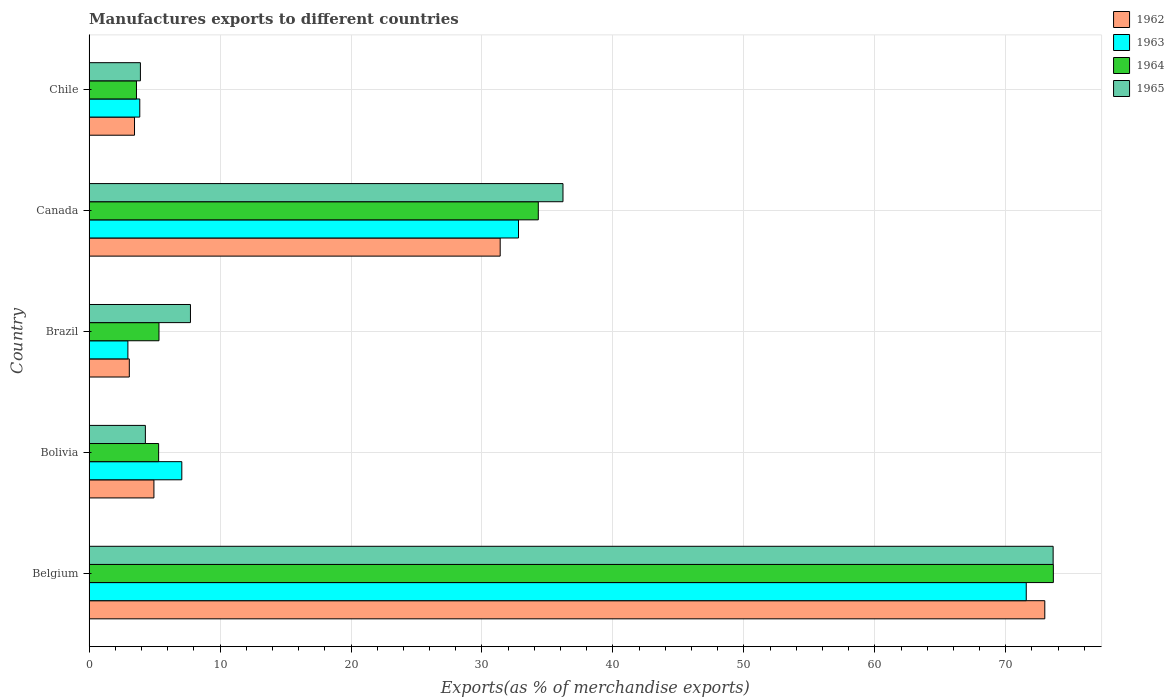How many different coloured bars are there?
Your answer should be compact. 4. How many groups of bars are there?
Your response must be concise. 5. Are the number of bars per tick equal to the number of legend labels?
Keep it short and to the point. Yes. Are the number of bars on each tick of the Y-axis equal?
Offer a very short reply. Yes. How many bars are there on the 3rd tick from the top?
Provide a short and direct response. 4. How many bars are there on the 3rd tick from the bottom?
Offer a terse response. 4. What is the percentage of exports to different countries in 1965 in Belgium?
Make the answer very short. 73.62. Across all countries, what is the maximum percentage of exports to different countries in 1964?
Offer a terse response. 73.63. Across all countries, what is the minimum percentage of exports to different countries in 1965?
Give a very brief answer. 3.92. In which country was the percentage of exports to different countries in 1964 maximum?
Give a very brief answer. Belgium. What is the total percentage of exports to different countries in 1962 in the graph?
Provide a short and direct response. 115.86. What is the difference between the percentage of exports to different countries in 1965 in Bolivia and that in Canada?
Make the answer very short. -31.89. What is the difference between the percentage of exports to different countries in 1965 in Bolivia and the percentage of exports to different countries in 1964 in Belgium?
Provide a short and direct response. -69.34. What is the average percentage of exports to different countries in 1963 per country?
Your answer should be very brief. 23.65. What is the difference between the percentage of exports to different countries in 1963 and percentage of exports to different countries in 1964 in Brazil?
Offer a very short reply. -2.37. What is the ratio of the percentage of exports to different countries in 1965 in Belgium to that in Canada?
Keep it short and to the point. 2.03. Is the percentage of exports to different countries in 1964 in Brazil less than that in Canada?
Give a very brief answer. Yes. What is the difference between the highest and the second highest percentage of exports to different countries in 1964?
Offer a very short reply. 39.33. What is the difference between the highest and the lowest percentage of exports to different countries in 1965?
Provide a succinct answer. 69.7. Is it the case that in every country, the sum of the percentage of exports to different countries in 1964 and percentage of exports to different countries in 1962 is greater than the percentage of exports to different countries in 1965?
Provide a short and direct response. Yes. Are all the bars in the graph horizontal?
Provide a short and direct response. Yes. What is the difference between two consecutive major ticks on the X-axis?
Ensure brevity in your answer.  10. Does the graph contain any zero values?
Your answer should be compact. No. Does the graph contain grids?
Provide a succinct answer. Yes. Where does the legend appear in the graph?
Provide a succinct answer. Top right. How are the legend labels stacked?
Provide a short and direct response. Vertical. What is the title of the graph?
Your answer should be very brief. Manufactures exports to different countries. Does "1985" appear as one of the legend labels in the graph?
Offer a terse response. No. What is the label or title of the X-axis?
Provide a succinct answer. Exports(as % of merchandise exports). What is the Exports(as % of merchandise exports) in 1962 in Belgium?
Provide a short and direct response. 72.98. What is the Exports(as % of merchandise exports) in 1963 in Belgium?
Offer a terse response. 71.56. What is the Exports(as % of merchandise exports) in 1964 in Belgium?
Offer a terse response. 73.63. What is the Exports(as % of merchandise exports) of 1965 in Belgium?
Your answer should be very brief. 73.62. What is the Exports(as % of merchandise exports) in 1962 in Bolivia?
Make the answer very short. 4.95. What is the Exports(as % of merchandise exports) in 1963 in Bolivia?
Provide a short and direct response. 7.08. What is the Exports(as % of merchandise exports) in 1964 in Bolivia?
Provide a short and direct response. 5.31. What is the Exports(as % of merchandise exports) of 1965 in Bolivia?
Your response must be concise. 4.3. What is the Exports(as % of merchandise exports) in 1962 in Brazil?
Your answer should be compact. 3.07. What is the Exports(as % of merchandise exports) in 1963 in Brazil?
Provide a short and direct response. 2.96. What is the Exports(as % of merchandise exports) of 1964 in Brazil?
Provide a short and direct response. 5.34. What is the Exports(as % of merchandise exports) in 1965 in Brazil?
Provide a short and direct response. 7.74. What is the Exports(as % of merchandise exports) of 1962 in Canada?
Your answer should be very brief. 31.39. What is the Exports(as % of merchandise exports) of 1963 in Canada?
Provide a short and direct response. 32.79. What is the Exports(as % of merchandise exports) of 1964 in Canada?
Provide a short and direct response. 34.3. What is the Exports(as % of merchandise exports) in 1965 in Canada?
Keep it short and to the point. 36.19. What is the Exports(as % of merchandise exports) in 1962 in Chile?
Provide a short and direct response. 3.47. What is the Exports(as % of merchandise exports) in 1963 in Chile?
Your response must be concise. 3.87. What is the Exports(as % of merchandise exports) of 1964 in Chile?
Your answer should be very brief. 3.62. What is the Exports(as % of merchandise exports) of 1965 in Chile?
Your answer should be very brief. 3.92. Across all countries, what is the maximum Exports(as % of merchandise exports) of 1962?
Offer a terse response. 72.98. Across all countries, what is the maximum Exports(as % of merchandise exports) of 1963?
Offer a very short reply. 71.56. Across all countries, what is the maximum Exports(as % of merchandise exports) of 1964?
Your answer should be compact. 73.63. Across all countries, what is the maximum Exports(as % of merchandise exports) of 1965?
Provide a short and direct response. 73.62. Across all countries, what is the minimum Exports(as % of merchandise exports) in 1962?
Give a very brief answer. 3.07. Across all countries, what is the minimum Exports(as % of merchandise exports) in 1963?
Your response must be concise. 2.96. Across all countries, what is the minimum Exports(as % of merchandise exports) of 1964?
Keep it short and to the point. 3.62. Across all countries, what is the minimum Exports(as % of merchandise exports) of 1965?
Keep it short and to the point. 3.92. What is the total Exports(as % of merchandise exports) of 1962 in the graph?
Offer a very short reply. 115.86. What is the total Exports(as % of merchandise exports) in 1963 in the graph?
Ensure brevity in your answer.  118.27. What is the total Exports(as % of merchandise exports) of 1964 in the graph?
Keep it short and to the point. 122.2. What is the total Exports(as % of merchandise exports) of 1965 in the graph?
Ensure brevity in your answer.  125.76. What is the difference between the Exports(as % of merchandise exports) in 1962 in Belgium and that in Bolivia?
Your answer should be very brief. 68.03. What is the difference between the Exports(as % of merchandise exports) in 1963 in Belgium and that in Bolivia?
Keep it short and to the point. 64.48. What is the difference between the Exports(as % of merchandise exports) of 1964 in Belgium and that in Bolivia?
Your answer should be very brief. 68.32. What is the difference between the Exports(as % of merchandise exports) in 1965 in Belgium and that in Bolivia?
Make the answer very short. 69.32. What is the difference between the Exports(as % of merchandise exports) in 1962 in Belgium and that in Brazil?
Make the answer very short. 69.91. What is the difference between the Exports(as % of merchandise exports) of 1963 in Belgium and that in Brazil?
Provide a succinct answer. 68.6. What is the difference between the Exports(as % of merchandise exports) of 1964 in Belgium and that in Brazil?
Make the answer very short. 68.3. What is the difference between the Exports(as % of merchandise exports) of 1965 in Belgium and that in Brazil?
Ensure brevity in your answer.  65.88. What is the difference between the Exports(as % of merchandise exports) in 1962 in Belgium and that in Canada?
Offer a terse response. 41.59. What is the difference between the Exports(as % of merchandise exports) of 1963 in Belgium and that in Canada?
Give a very brief answer. 38.77. What is the difference between the Exports(as % of merchandise exports) in 1964 in Belgium and that in Canada?
Ensure brevity in your answer.  39.33. What is the difference between the Exports(as % of merchandise exports) of 1965 in Belgium and that in Canada?
Your response must be concise. 37.43. What is the difference between the Exports(as % of merchandise exports) in 1962 in Belgium and that in Chile?
Your answer should be very brief. 69.51. What is the difference between the Exports(as % of merchandise exports) in 1963 in Belgium and that in Chile?
Keep it short and to the point. 67.69. What is the difference between the Exports(as % of merchandise exports) of 1964 in Belgium and that in Chile?
Ensure brevity in your answer.  70.02. What is the difference between the Exports(as % of merchandise exports) in 1965 in Belgium and that in Chile?
Offer a terse response. 69.7. What is the difference between the Exports(as % of merchandise exports) in 1962 in Bolivia and that in Brazil?
Offer a very short reply. 1.88. What is the difference between the Exports(as % of merchandise exports) of 1963 in Bolivia and that in Brazil?
Keep it short and to the point. 4.12. What is the difference between the Exports(as % of merchandise exports) of 1964 in Bolivia and that in Brazil?
Keep it short and to the point. -0.03. What is the difference between the Exports(as % of merchandise exports) in 1965 in Bolivia and that in Brazil?
Offer a terse response. -3.44. What is the difference between the Exports(as % of merchandise exports) in 1962 in Bolivia and that in Canada?
Keep it short and to the point. -26.44. What is the difference between the Exports(as % of merchandise exports) in 1963 in Bolivia and that in Canada?
Ensure brevity in your answer.  -25.71. What is the difference between the Exports(as % of merchandise exports) in 1964 in Bolivia and that in Canada?
Provide a succinct answer. -28.99. What is the difference between the Exports(as % of merchandise exports) of 1965 in Bolivia and that in Canada?
Provide a succinct answer. -31.89. What is the difference between the Exports(as % of merchandise exports) of 1962 in Bolivia and that in Chile?
Make the answer very short. 1.48. What is the difference between the Exports(as % of merchandise exports) of 1963 in Bolivia and that in Chile?
Make the answer very short. 3.21. What is the difference between the Exports(as % of merchandise exports) in 1964 in Bolivia and that in Chile?
Ensure brevity in your answer.  1.69. What is the difference between the Exports(as % of merchandise exports) of 1965 in Bolivia and that in Chile?
Make the answer very short. 0.38. What is the difference between the Exports(as % of merchandise exports) of 1962 in Brazil and that in Canada?
Provide a succinct answer. -28.32. What is the difference between the Exports(as % of merchandise exports) of 1963 in Brazil and that in Canada?
Ensure brevity in your answer.  -29.83. What is the difference between the Exports(as % of merchandise exports) of 1964 in Brazil and that in Canada?
Ensure brevity in your answer.  -28.97. What is the difference between the Exports(as % of merchandise exports) of 1965 in Brazil and that in Canada?
Give a very brief answer. -28.45. What is the difference between the Exports(as % of merchandise exports) of 1962 in Brazil and that in Chile?
Provide a succinct answer. -0.4. What is the difference between the Exports(as % of merchandise exports) of 1963 in Brazil and that in Chile?
Your response must be concise. -0.91. What is the difference between the Exports(as % of merchandise exports) in 1964 in Brazil and that in Chile?
Give a very brief answer. 1.72. What is the difference between the Exports(as % of merchandise exports) in 1965 in Brazil and that in Chile?
Provide a short and direct response. 3.82. What is the difference between the Exports(as % of merchandise exports) of 1962 in Canada and that in Chile?
Offer a terse response. 27.92. What is the difference between the Exports(as % of merchandise exports) in 1963 in Canada and that in Chile?
Keep it short and to the point. 28.92. What is the difference between the Exports(as % of merchandise exports) of 1964 in Canada and that in Chile?
Your response must be concise. 30.69. What is the difference between the Exports(as % of merchandise exports) of 1965 in Canada and that in Chile?
Keep it short and to the point. 32.27. What is the difference between the Exports(as % of merchandise exports) of 1962 in Belgium and the Exports(as % of merchandise exports) of 1963 in Bolivia?
Your answer should be very brief. 65.9. What is the difference between the Exports(as % of merchandise exports) of 1962 in Belgium and the Exports(as % of merchandise exports) of 1964 in Bolivia?
Make the answer very short. 67.67. What is the difference between the Exports(as % of merchandise exports) in 1962 in Belgium and the Exports(as % of merchandise exports) in 1965 in Bolivia?
Ensure brevity in your answer.  68.68. What is the difference between the Exports(as % of merchandise exports) of 1963 in Belgium and the Exports(as % of merchandise exports) of 1964 in Bolivia?
Offer a very short reply. 66.25. What is the difference between the Exports(as % of merchandise exports) in 1963 in Belgium and the Exports(as % of merchandise exports) in 1965 in Bolivia?
Offer a very short reply. 67.27. What is the difference between the Exports(as % of merchandise exports) in 1964 in Belgium and the Exports(as % of merchandise exports) in 1965 in Bolivia?
Provide a succinct answer. 69.34. What is the difference between the Exports(as % of merchandise exports) in 1962 in Belgium and the Exports(as % of merchandise exports) in 1963 in Brazil?
Make the answer very short. 70.02. What is the difference between the Exports(as % of merchandise exports) in 1962 in Belgium and the Exports(as % of merchandise exports) in 1964 in Brazil?
Keep it short and to the point. 67.64. What is the difference between the Exports(as % of merchandise exports) in 1962 in Belgium and the Exports(as % of merchandise exports) in 1965 in Brazil?
Your answer should be compact. 65.24. What is the difference between the Exports(as % of merchandise exports) in 1963 in Belgium and the Exports(as % of merchandise exports) in 1964 in Brazil?
Provide a succinct answer. 66.23. What is the difference between the Exports(as % of merchandise exports) of 1963 in Belgium and the Exports(as % of merchandise exports) of 1965 in Brazil?
Offer a very short reply. 63.82. What is the difference between the Exports(as % of merchandise exports) of 1964 in Belgium and the Exports(as % of merchandise exports) of 1965 in Brazil?
Offer a terse response. 65.89. What is the difference between the Exports(as % of merchandise exports) of 1962 in Belgium and the Exports(as % of merchandise exports) of 1963 in Canada?
Your answer should be very brief. 40.19. What is the difference between the Exports(as % of merchandise exports) of 1962 in Belgium and the Exports(as % of merchandise exports) of 1964 in Canada?
Provide a short and direct response. 38.68. What is the difference between the Exports(as % of merchandise exports) of 1962 in Belgium and the Exports(as % of merchandise exports) of 1965 in Canada?
Give a very brief answer. 36.79. What is the difference between the Exports(as % of merchandise exports) of 1963 in Belgium and the Exports(as % of merchandise exports) of 1964 in Canada?
Give a very brief answer. 37.26. What is the difference between the Exports(as % of merchandise exports) of 1963 in Belgium and the Exports(as % of merchandise exports) of 1965 in Canada?
Make the answer very short. 35.38. What is the difference between the Exports(as % of merchandise exports) of 1964 in Belgium and the Exports(as % of merchandise exports) of 1965 in Canada?
Offer a terse response. 37.44. What is the difference between the Exports(as % of merchandise exports) in 1962 in Belgium and the Exports(as % of merchandise exports) in 1963 in Chile?
Provide a short and direct response. 69.11. What is the difference between the Exports(as % of merchandise exports) in 1962 in Belgium and the Exports(as % of merchandise exports) in 1964 in Chile?
Provide a succinct answer. 69.36. What is the difference between the Exports(as % of merchandise exports) in 1962 in Belgium and the Exports(as % of merchandise exports) in 1965 in Chile?
Your answer should be very brief. 69.06. What is the difference between the Exports(as % of merchandise exports) in 1963 in Belgium and the Exports(as % of merchandise exports) in 1964 in Chile?
Offer a very short reply. 67.95. What is the difference between the Exports(as % of merchandise exports) in 1963 in Belgium and the Exports(as % of merchandise exports) in 1965 in Chile?
Give a very brief answer. 67.65. What is the difference between the Exports(as % of merchandise exports) in 1964 in Belgium and the Exports(as % of merchandise exports) in 1965 in Chile?
Offer a terse response. 69.71. What is the difference between the Exports(as % of merchandise exports) of 1962 in Bolivia and the Exports(as % of merchandise exports) of 1963 in Brazil?
Your answer should be compact. 1.99. What is the difference between the Exports(as % of merchandise exports) of 1962 in Bolivia and the Exports(as % of merchandise exports) of 1964 in Brazil?
Offer a terse response. -0.39. What is the difference between the Exports(as % of merchandise exports) of 1962 in Bolivia and the Exports(as % of merchandise exports) of 1965 in Brazil?
Keep it short and to the point. -2.79. What is the difference between the Exports(as % of merchandise exports) of 1963 in Bolivia and the Exports(as % of merchandise exports) of 1964 in Brazil?
Ensure brevity in your answer.  1.74. What is the difference between the Exports(as % of merchandise exports) in 1963 in Bolivia and the Exports(as % of merchandise exports) in 1965 in Brazil?
Your answer should be very brief. -0.66. What is the difference between the Exports(as % of merchandise exports) in 1964 in Bolivia and the Exports(as % of merchandise exports) in 1965 in Brazil?
Offer a very short reply. -2.43. What is the difference between the Exports(as % of merchandise exports) of 1962 in Bolivia and the Exports(as % of merchandise exports) of 1963 in Canada?
Your answer should be very brief. -27.84. What is the difference between the Exports(as % of merchandise exports) in 1962 in Bolivia and the Exports(as % of merchandise exports) in 1964 in Canada?
Your answer should be very brief. -29.35. What is the difference between the Exports(as % of merchandise exports) of 1962 in Bolivia and the Exports(as % of merchandise exports) of 1965 in Canada?
Ensure brevity in your answer.  -31.24. What is the difference between the Exports(as % of merchandise exports) of 1963 in Bolivia and the Exports(as % of merchandise exports) of 1964 in Canada?
Offer a terse response. -27.22. What is the difference between the Exports(as % of merchandise exports) in 1963 in Bolivia and the Exports(as % of merchandise exports) in 1965 in Canada?
Your response must be concise. -29.11. What is the difference between the Exports(as % of merchandise exports) in 1964 in Bolivia and the Exports(as % of merchandise exports) in 1965 in Canada?
Provide a short and direct response. -30.88. What is the difference between the Exports(as % of merchandise exports) in 1962 in Bolivia and the Exports(as % of merchandise exports) in 1963 in Chile?
Provide a succinct answer. 1.08. What is the difference between the Exports(as % of merchandise exports) in 1962 in Bolivia and the Exports(as % of merchandise exports) in 1964 in Chile?
Provide a succinct answer. 1.33. What is the difference between the Exports(as % of merchandise exports) in 1962 in Bolivia and the Exports(as % of merchandise exports) in 1965 in Chile?
Provide a succinct answer. 1.03. What is the difference between the Exports(as % of merchandise exports) of 1963 in Bolivia and the Exports(as % of merchandise exports) of 1964 in Chile?
Your answer should be very brief. 3.46. What is the difference between the Exports(as % of merchandise exports) in 1963 in Bolivia and the Exports(as % of merchandise exports) in 1965 in Chile?
Your answer should be compact. 3.16. What is the difference between the Exports(as % of merchandise exports) in 1964 in Bolivia and the Exports(as % of merchandise exports) in 1965 in Chile?
Keep it short and to the point. 1.39. What is the difference between the Exports(as % of merchandise exports) of 1962 in Brazil and the Exports(as % of merchandise exports) of 1963 in Canada?
Your answer should be very brief. -29.72. What is the difference between the Exports(as % of merchandise exports) in 1962 in Brazil and the Exports(as % of merchandise exports) in 1964 in Canada?
Give a very brief answer. -31.23. What is the difference between the Exports(as % of merchandise exports) of 1962 in Brazil and the Exports(as % of merchandise exports) of 1965 in Canada?
Your answer should be very brief. -33.12. What is the difference between the Exports(as % of merchandise exports) in 1963 in Brazil and the Exports(as % of merchandise exports) in 1964 in Canada?
Offer a terse response. -31.34. What is the difference between the Exports(as % of merchandise exports) in 1963 in Brazil and the Exports(as % of merchandise exports) in 1965 in Canada?
Give a very brief answer. -33.23. What is the difference between the Exports(as % of merchandise exports) of 1964 in Brazil and the Exports(as % of merchandise exports) of 1965 in Canada?
Offer a terse response. -30.85. What is the difference between the Exports(as % of merchandise exports) in 1962 in Brazil and the Exports(as % of merchandise exports) in 1963 in Chile?
Offer a terse response. -0.8. What is the difference between the Exports(as % of merchandise exports) in 1962 in Brazil and the Exports(as % of merchandise exports) in 1964 in Chile?
Keep it short and to the point. -0.55. What is the difference between the Exports(as % of merchandise exports) of 1962 in Brazil and the Exports(as % of merchandise exports) of 1965 in Chile?
Provide a succinct answer. -0.85. What is the difference between the Exports(as % of merchandise exports) of 1963 in Brazil and the Exports(as % of merchandise exports) of 1964 in Chile?
Provide a succinct answer. -0.66. What is the difference between the Exports(as % of merchandise exports) in 1963 in Brazil and the Exports(as % of merchandise exports) in 1965 in Chile?
Provide a short and direct response. -0.96. What is the difference between the Exports(as % of merchandise exports) in 1964 in Brazil and the Exports(as % of merchandise exports) in 1965 in Chile?
Your answer should be compact. 1.42. What is the difference between the Exports(as % of merchandise exports) in 1962 in Canada and the Exports(as % of merchandise exports) in 1963 in Chile?
Offer a terse response. 27.52. What is the difference between the Exports(as % of merchandise exports) in 1962 in Canada and the Exports(as % of merchandise exports) in 1964 in Chile?
Offer a very short reply. 27.77. What is the difference between the Exports(as % of merchandise exports) in 1962 in Canada and the Exports(as % of merchandise exports) in 1965 in Chile?
Your answer should be very brief. 27.47. What is the difference between the Exports(as % of merchandise exports) in 1963 in Canada and the Exports(as % of merchandise exports) in 1964 in Chile?
Give a very brief answer. 29.17. What is the difference between the Exports(as % of merchandise exports) in 1963 in Canada and the Exports(as % of merchandise exports) in 1965 in Chile?
Give a very brief answer. 28.87. What is the difference between the Exports(as % of merchandise exports) of 1964 in Canada and the Exports(as % of merchandise exports) of 1965 in Chile?
Provide a short and direct response. 30.39. What is the average Exports(as % of merchandise exports) of 1962 per country?
Your answer should be very brief. 23.17. What is the average Exports(as % of merchandise exports) of 1963 per country?
Keep it short and to the point. 23.65. What is the average Exports(as % of merchandise exports) of 1964 per country?
Give a very brief answer. 24.44. What is the average Exports(as % of merchandise exports) of 1965 per country?
Provide a succinct answer. 25.15. What is the difference between the Exports(as % of merchandise exports) in 1962 and Exports(as % of merchandise exports) in 1963 in Belgium?
Give a very brief answer. 1.42. What is the difference between the Exports(as % of merchandise exports) in 1962 and Exports(as % of merchandise exports) in 1964 in Belgium?
Offer a very short reply. -0.65. What is the difference between the Exports(as % of merchandise exports) of 1962 and Exports(as % of merchandise exports) of 1965 in Belgium?
Provide a short and direct response. -0.64. What is the difference between the Exports(as % of merchandise exports) in 1963 and Exports(as % of merchandise exports) in 1964 in Belgium?
Your response must be concise. -2.07. What is the difference between the Exports(as % of merchandise exports) in 1963 and Exports(as % of merchandise exports) in 1965 in Belgium?
Provide a short and direct response. -2.05. What is the difference between the Exports(as % of merchandise exports) in 1964 and Exports(as % of merchandise exports) in 1965 in Belgium?
Provide a succinct answer. 0.02. What is the difference between the Exports(as % of merchandise exports) in 1962 and Exports(as % of merchandise exports) in 1963 in Bolivia?
Your answer should be compact. -2.13. What is the difference between the Exports(as % of merchandise exports) of 1962 and Exports(as % of merchandise exports) of 1964 in Bolivia?
Give a very brief answer. -0.36. What is the difference between the Exports(as % of merchandise exports) of 1962 and Exports(as % of merchandise exports) of 1965 in Bolivia?
Offer a very short reply. 0.65. What is the difference between the Exports(as % of merchandise exports) in 1963 and Exports(as % of merchandise exports) in 1964 in Bolivia?
Offer a terse response. 1.77. What is the difference between the Exports(as % of merchandise exports) of 1963 and Exports(as % of merchandise exports) of 1965 in Bolivia?
Your answer should be compact. 2.78. What is the difference between the Exports(as % of merchandise exports) in 1964 and Exports(as % of merchandise exports) in 1965 in Bolivia?
Provide a succinct answer. 1.01. What is the difference between the Exports(as % of merchandise exports) of 1962 and Exports(as % of merchandise exports) of 1963 in Brazil?
Your response must be concise. 0.11. What is the difference between the Exports(as % of merchandise exports) of 1962 and Exports(as % of merchandise exports) of 1964 in Brazil?
Provide a short and direct response. -2.27. What is the difference between the Exports(as % of merchandise exports) of 1962 and Exports(as % of merchandise exports) of 1965 in Brazil?
Ensure brevity in your answer.  -4.67. What is the difference between the Exports(as % of merchandise exports) in 1963 and Exports(as % of merchandise exports) in 1964 in Brazil?
Offer a very short reply. -2.37. What is the difference between the Exports(as % of merchandise exports) in 1963 and Exports(as % of merchandise exports) in 1965 in Brazil?
Provide a short and direct response. -4.78. What is the difference between the Exports(as % of merchandise exports) in 1964 and Exports(as % of merchandise exports) in 1965 in Brazil?
Offer a terse response. -2.4. What is the difference between the Exports(as % of merchandise exports) of 1962 and Exports(as % of merchandise exports) of 1963 in Canada?
Keep it short and to the point. -1.4. What is the difference between the Exports(as % of merchandise exports) of 1962 and Exports(as % of merchandise exports) of 1964 in Canada?
Ensure brevity in your answer.  -2.91. What is the difference between the Exports(as % of merchandise exports) of 1962 and Exports(as % of merchandise exports) of 1965 in Canada?
Your answer should be compact. -4.8. What is the difference between the Exports(as % of merchandise exports) in 1963 and Exports(as % of merchandise exports) in 1964 in Canada?
Your response must be concise. -1.51. What is the difference between the Exports(as % of merchandise exports) of 1963 and Exports(as % of merchandise exports) of 1965 in Canada?
Your answer should be compact. -3.4. What is the difference between the Exports(as % of merchandise exports) of 1964 and Exports(as % of merchandise exports) of 1965 in Canada?
Your answer should be compact. -1.89. What is the difference between the Exports(as % of merchandise exports) of 1962 and Exports(as % of merchandise exports) of 1963 in Chile?
Keep it short and to the point. -0.4. What is the difference between the Exports(as % of merchandise exports) in 1962 and Exports(as % of merchandise exports) in 1964 in Chile?
Give a very brief answer. -0.15. What is the difference between the Exports(as % of merchandise exports) in 1962 and Exports(as % of merchandise exports) in 1965 in Chile?
Offer a very short reply. -0.45. What is the difference between the Exports(as % of merchandise exports) in 1963 and Exports(as % of merchandise exports) in 1964 in Chile?
Offer a terse response. 0.25. What is the difference between the Exports(as % of merchandise exports) of 1963 and Exports(as % of merchandise exports) of 1965 in Chile?
Keep it short and to the point. -0.05. What is the difference between the Exports(as % of merchandise exports) in 1964 and Exports(as % of merchandise exports) in 1965 in Chile?
Keep it short and to the point. -0.3. What is the ratio of the Exports(as % of merchandise exports) in 1962 in Belgium to that in Bolivia?
Offer a very short reply. 14.74. What is the ratio of the Exports(as % of merchandise exports) of 1963 in Belgium to that in Bolivia?
Your answer should be very brief. 10.11. What is the ratio of the Exports(as % of merchandise exports) in 1964 in Belgium to that in Bolivia?
Offer a very short reply. 13.87. What is the ratio of the Exports(as % of merchandise exports) of 1965 in Belgium to that in Bolivia?
Make the answer very short. 17.13. What is the ratio of the Exports(as % of merchandise exports) in 1962 in Belgium to that in Brazil?
Your answer should be very brief. 23.77. What is the ratio of the Exports(as % of merchandise exports) of 1963 in Belgium to that in Brazil?
Ensure brevity in your answer.  24.16. What is the ratio of the Exports(as % of merchandise exports) in 1964 in Belgium to that in Brazil?
Offer a very short reply. 13.8. What is the ratio of the Exports(as % of merchandise exports) in 1965 in Belgium to that in Brazil?
Your response must be concise. 9.51. What is the ratio of the Exports(as % of merchandise exports) of 1962 in Belgium to that in Canada?
Offer a very short reply. 2.32. What is the ratio of the Exports(as % of merchandise exports) in 1963 in Belgium to that in Canada?
Your answer should be compact. 2.18. What is the ratio of the Exports(as % of merchandise exports) of 1964 in Belgium to that in Canada?
Provide a succinct answer. 2.15. What is the ratio of the Exports(as % of merchandise exports) of 1965 in Belgium to that in Canada?
Your response must be concise. 2.03. What is the ratio of the Exports(as % of merchandise exports) of 1962 in Belgium to that in Chile?
Keep it short and to the point. 21.04. What is the ratio of the Exports(as % of merchandise exports) of 1963 in Belgium to that in Chile?
Your answer should be very brief. 18.49. What is the ratio of the Exports(as % of merchandise exports) of 1964 in Belgium to that in Chile?
Your answer should be very brief. 20.35. What is the ratio of the Exports(as % of merchandise exports) in 1965 in Belgium to that in Chile?
Keep it short and to the point. 18.79. What is the ratio of the Exports(as % of merchandise exports) of 1962 in Bolivia to that in Brazil?
Provide a short and direct response. 1.61. What is the ratio of the Exports(as % of merchandise exports) in 1963 in Bolivia to that in Brazil?
Ensure brevity in your answer.  2.39. What is the ratio of the Exports(as % of merchandise exports) of 1964 in Bolivia to that in Brazil?
Keep it short and to the point. 0.99. What is the ratio of the Exports(as % of merchandise exports) of 1965 in Bolivia to that in Brazil?
Your response must be concise. 0.56. What is the ratio of the Exports(as % of merchandise exports) of 1962 in Bolivia to that in Canada?
Offer a very short reply. 0.16. What is the ratio of the Exports(as % of merchandise exports) in 1963 in Bolivia to that in Canada?
Keep it short and to the point. 0.22. What is the ratio of the Exports(as % of merchandise exports) of 1964 in Bolivia to that in Canada?
Give a very brief answer. 0.15. What is the ratio of the Exports(as % of merchandise exports) in 1965 in Bolivia to that in Canada?
Provide a short and direct response. 0.12. What is the ratio of the Exports(as % of merchandise exports) of 1962 in Bolivia to that in Chile?
Ensure brevity in your answer.  1.43. What is the ratio of the Exports(as % of merchandise exports) of 1963 in Bolivia to that in Chile?
Keep it short and to the point. 1.83. What is the ratio of the Exports(as % of merchandise exports) of 1964 in Bolivia to that in Chile?
Keep it short and to the point. 1.47. What is the ratio of the Exports(as % of merchandise exports) in 1965 in Bolivia to that in Chile?
Your response must be concise. 1.1. What is the ratio of the Exports(as % of merchandise exports) of 1962 in Brazil to that in Canada?
Your answer should be very brief. 0.1. What is the ratio of the Exports(as % of merchandise exports) in 1963 in Brazil to that in Canada?
Keep it short and to the point. 0.09. What is the ratio of the Exports(as % of merchandise exports) in 1964 in Brazil to that in Canada?
Provide a succinct answer. 0.16. What is the ratio of the Exports(as % of merchandise exports) of 1965 in Brazil to that in Canada?
Offer a terse response. 0.21. What is the ratio of the Exports(as % of merchandise exports) of 1962 in Brazil to that in Chile?
Give a very brief answer. 0.89. What is the ratio of the Exports(as % of merchandise exports) of 1963 in Brazil to that in Chile?
Keep it short and to the point. 0.77. What is the ratio of the Exports(as % of merchandise exports) in 1964 in Brazil to that in Chile?
Ensure brevity in your answer.  1.48. What is the ratio of the Exports(as % of merchandise exports) in 1965 in Brazil to that in Chile?
Offer a terse response. 1.98. What is the ratio of the Exports(as % of merchandise exports) of 1962 in Canada to that in Chile?
Make the answer very short. 9.05. What is the ratio of the Exports(as % of merchandise exports) in 1963 in Canada to that in Chile?
Your response must be concise. 8.47. What is the ratio of the Exports(as % of merchandise exports) of 1964 in Canada to that in Chile?
Your answer should be very brief. 9.48. What is the ratio of the Exports(as % of merchandise exports) in 1965 in Canada to that in Chile?
Your answer should be compact. 9.24. What is the difference between the highest and the second highest Exports(as % of merchandise exports) of 1962?
Provide a succinct answer. 41.59. What is the difference between the highest and the second highest Exports(as % of merchandise exports) of 1963?
Provide a succinct answer. 38.77. What is the difference between the highest and the second highest Exports(as % of merchandise exports) in 1964?
Provide a succinct answer. 39.33. What is the difference between the highest and the second highest Exports(as % of merchandise exports) in 1965?
Your answer should be very brief. 37.43. What is the difference between the highest and the lowest Exports(as % of merchandise exports) of 1962?
Your answer should be very brief. 69.91. What is the difference between the highest and the lowest Exports(as % of merchandise exports) of 1963?
Keep it short and to the point. 68.6. What is the difference between the highest and the lowest Exports(as % of merchandise exports) of 1964?
Your answer should be compact. 70.02. What is the difference between the highest and the lowest Exports(as % of merchandise exports) of 1965?
Keep it short and to the point. 69.7. 